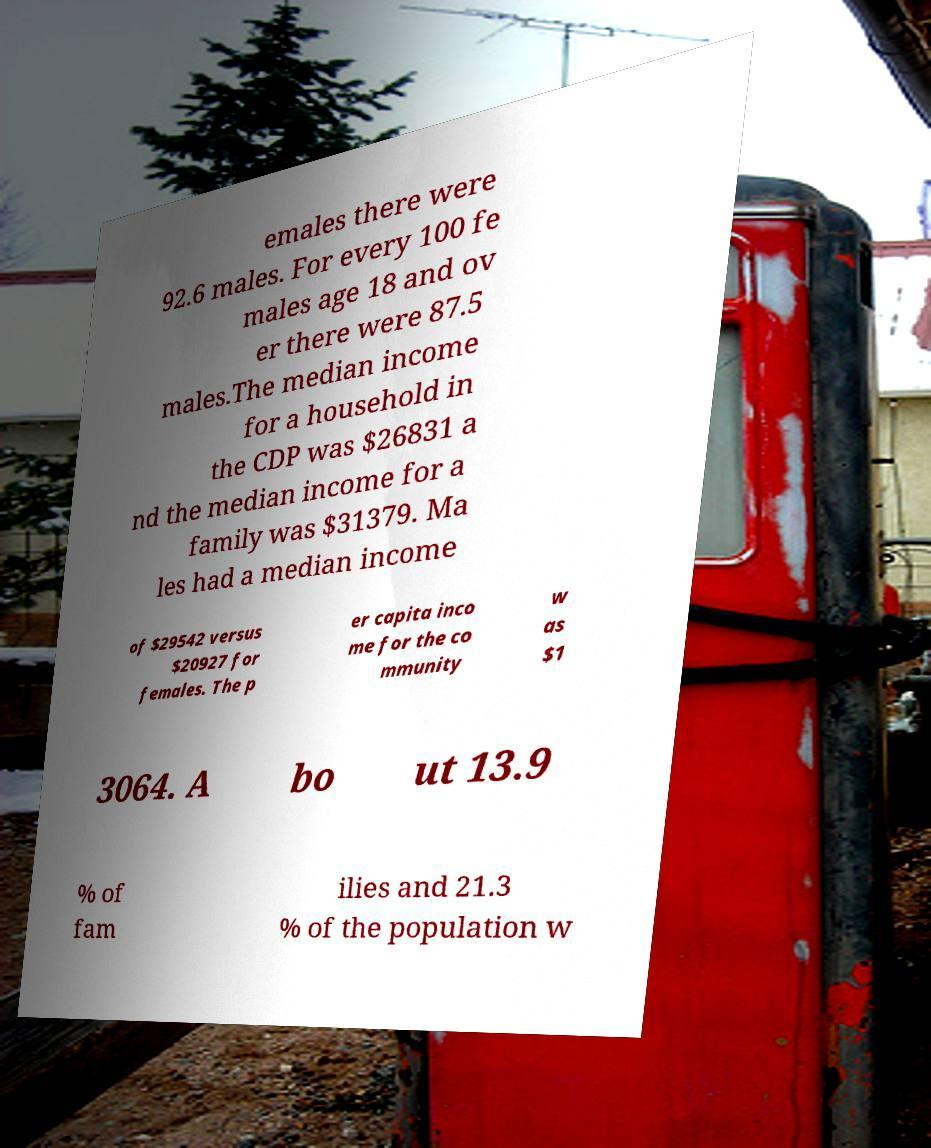What messages or text are displayed in this image? I need them in a readable, typed format. emales there were 92.6 males. For every 100 fe males age 18 and ov er there were 87.5 males.The median income for a household in the CDP was $26831 a nd the median income for a family was $31379. Ma les had a median income of $29542 versus $20927 for females. The p er capita inco me for the co mmunity w as $1 3064. A bo ut 13.9 % of fam ilies and 21.3 % of the population w 